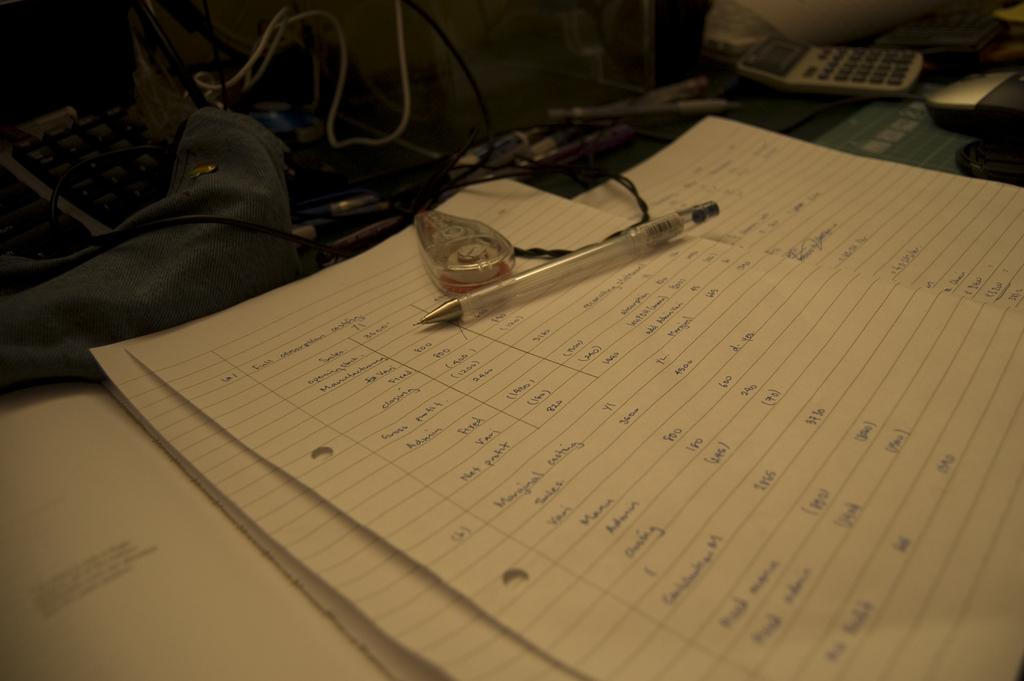What object is placed on top of the book in the image? There is a pen on a book in the image. What else can be seen in the image besides the pen and book? Wires are visible in the image. What device is present in the image that is commonly used for calculations? There is a calculator present in the image. What is the condition of the cellar in the image? There is no cellar present in the image. How many parcels can be seen in the image? There are no parcels visible in the image. 